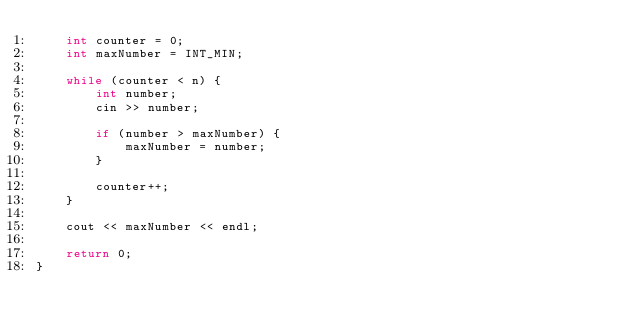<code> <loc_0><loc_0><loc_500><loc_500><_C++_>    int counter = 0;
    int maxNumber = INT_MIN;

    while (counter < n) {
        int number;
        cin >> number;

        if (number > maxNumber) {
            maxNumber = number;
        }

        counter++;
    }

    cout << maxNumber << endl;

    return 0;
}</code> 